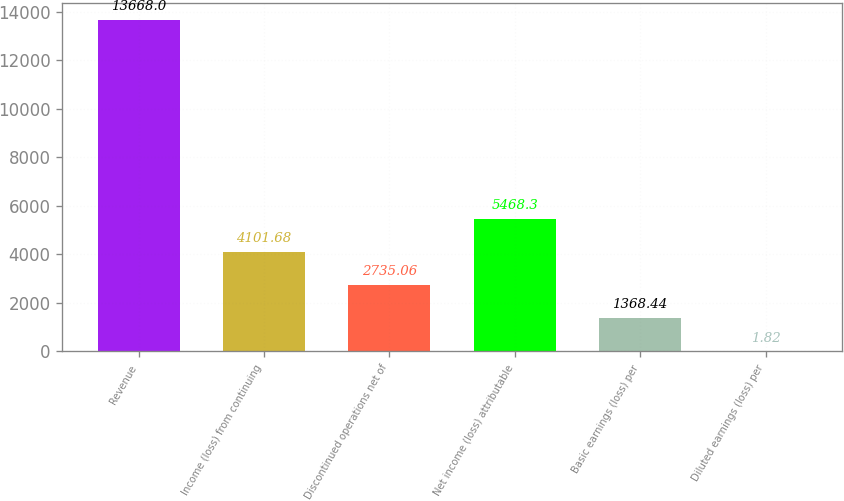Convert chart to OTSL. <chart><loc_0><loc_0><loc_500><loc_500><bar_chart><fcel>Revenue<fcel>Income (loss) from continuing<fcel>Discontinued operations net of<fcel>Net income (loss) attributable<fcel>Basic earnings (loss) per<fcel>Diluted earnings (loss) per<nl><fcel>13668<fcel>4101.68<fcel>2735.06<fcel>5468.3<fcel>1368.44<fcel>1.82<nl></chart> 